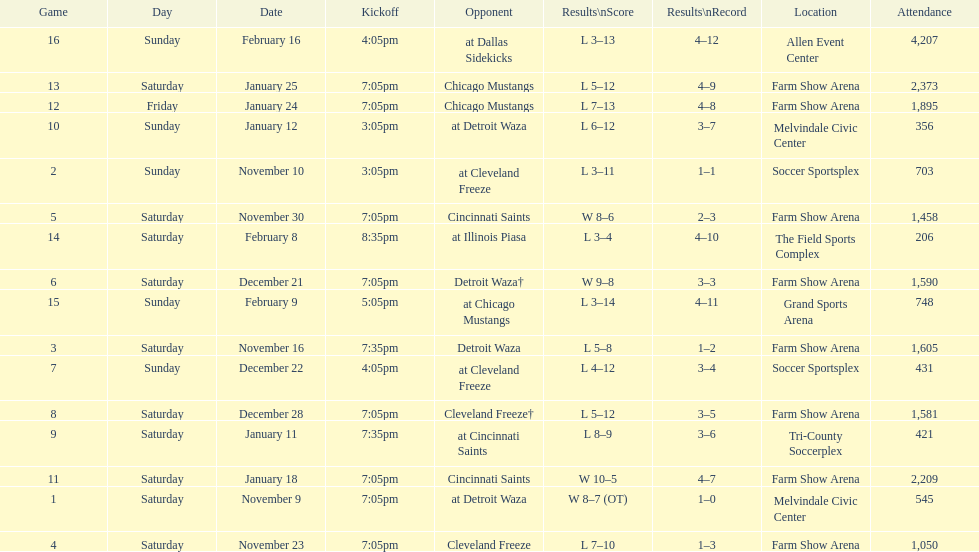How many games did the harrisburg heat lose to the cleveland freeze in total. 4. 